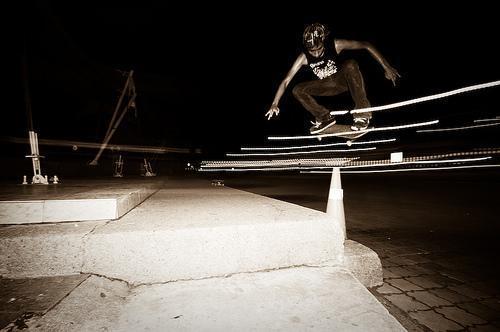How many horses are there?
Give a very brief answer. 0. 